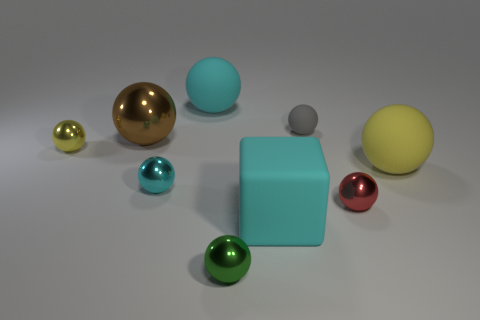Subtract 1 balls. How many balls are left? 7 Subtract all green balls. How many balls are left? 7 Subtract all small red metallic spheres. How many spheres are left? 7 Subtract all blue spheres. Subtract all blue blocks. How many spheres are left? 8 Add 1 big yellow balls. How many objects exist? 10 Subtract all balls. How many objects are left? 1 Add 4 green objects. How many green objects exist? 5 Subtract 0 yellow cylinders. How many objects are left? 9 Subtract all cyan cubes. Subtract all blue cylinders. How many objects are left? 8 Add 6 cyan balls. How many cyan balls are left? 8 